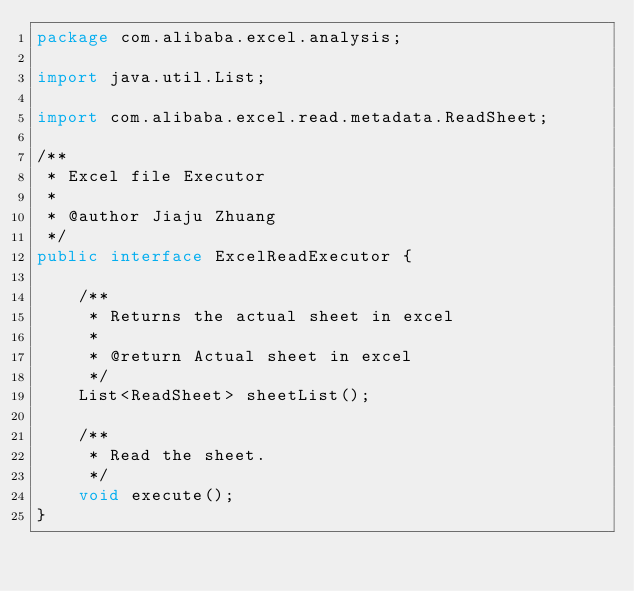Convert code to text. <code><loc_0><loc_0><loc_500><loc_500><_Java_>package com.alibaba.excel.analysis;

import java.util.List;

import com.alibaba.excel.read.metadata.ReadSheet;

/**
 * Excel file Executor
 *
 * @author Jiaju Zhuang
 */
public interface ExcelReadExecutor {

    /**
     * Returns the actual sheet in excel
     *
     * @return Actual sheet in excel
     */
    List<ReadSheet> sheetList();

    /**
     * Read the sheet.
     */
    void execute();
}
</code> 